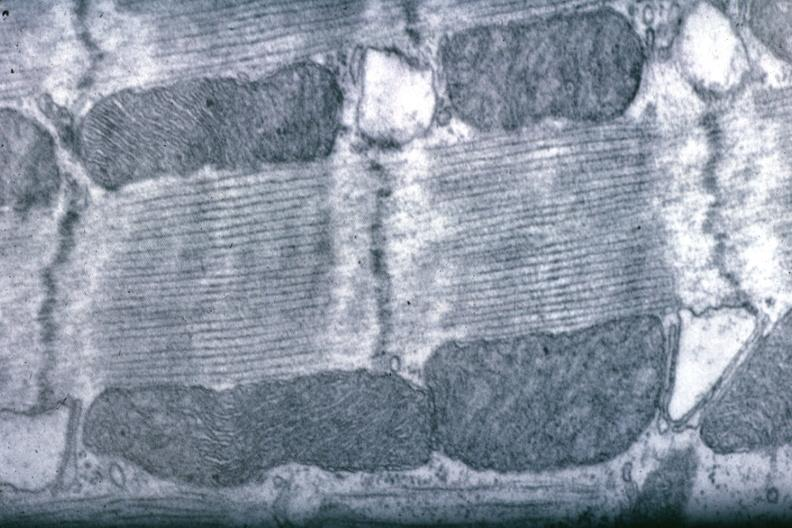does this image show good for banding pattern mitochondria?
Answer the question using a single word or phrase. Yes 